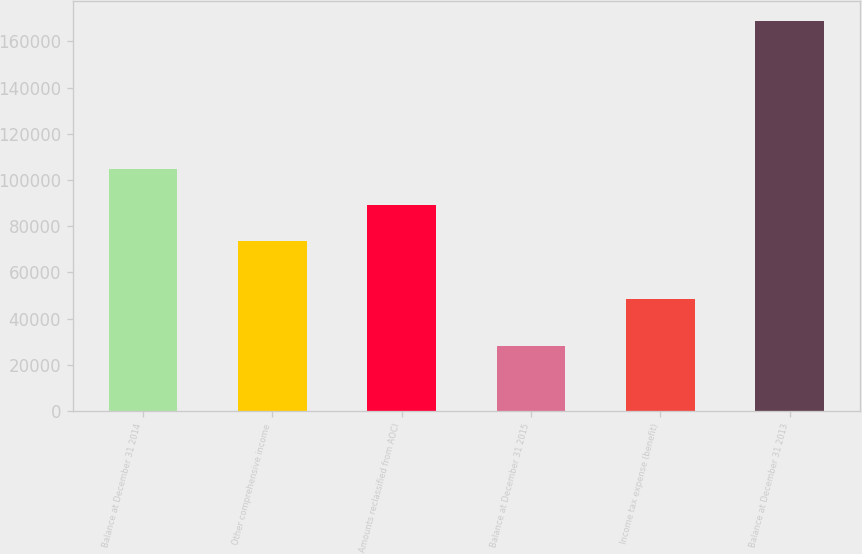Convert chart. <chart><loc_0><loc_0><loc_500><loc_500><bar_chart><fcel>Balance at December 31 2014<fcel>Other comprehensive income<fcel>Amounts reclassified from AOCI<fcel>Balance at December 31 2015<fcel>Income tax expense (benefit)<fcel>Balance at December 31 2013<nl><fcel>104819<fcel>73552<fcel>89185.4<fcel>28104.4<fcel>48422<fcel>168805<nl></chart> 